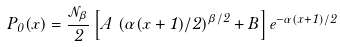Convert formula to latex. <formula><loc_0><loc_0><loc_500><loc_500>P _ { 0 } ( x ) = \frac { { \mathcal { N } } _ { \beta } } { 2 } \left [ A \, \left ( \alpha ( x + 1 ) / 2 \right ) ^ { \beta / 2 } + B \right ] e ^ { - \alpha ( x + 1 ) / 2 }</formula> 